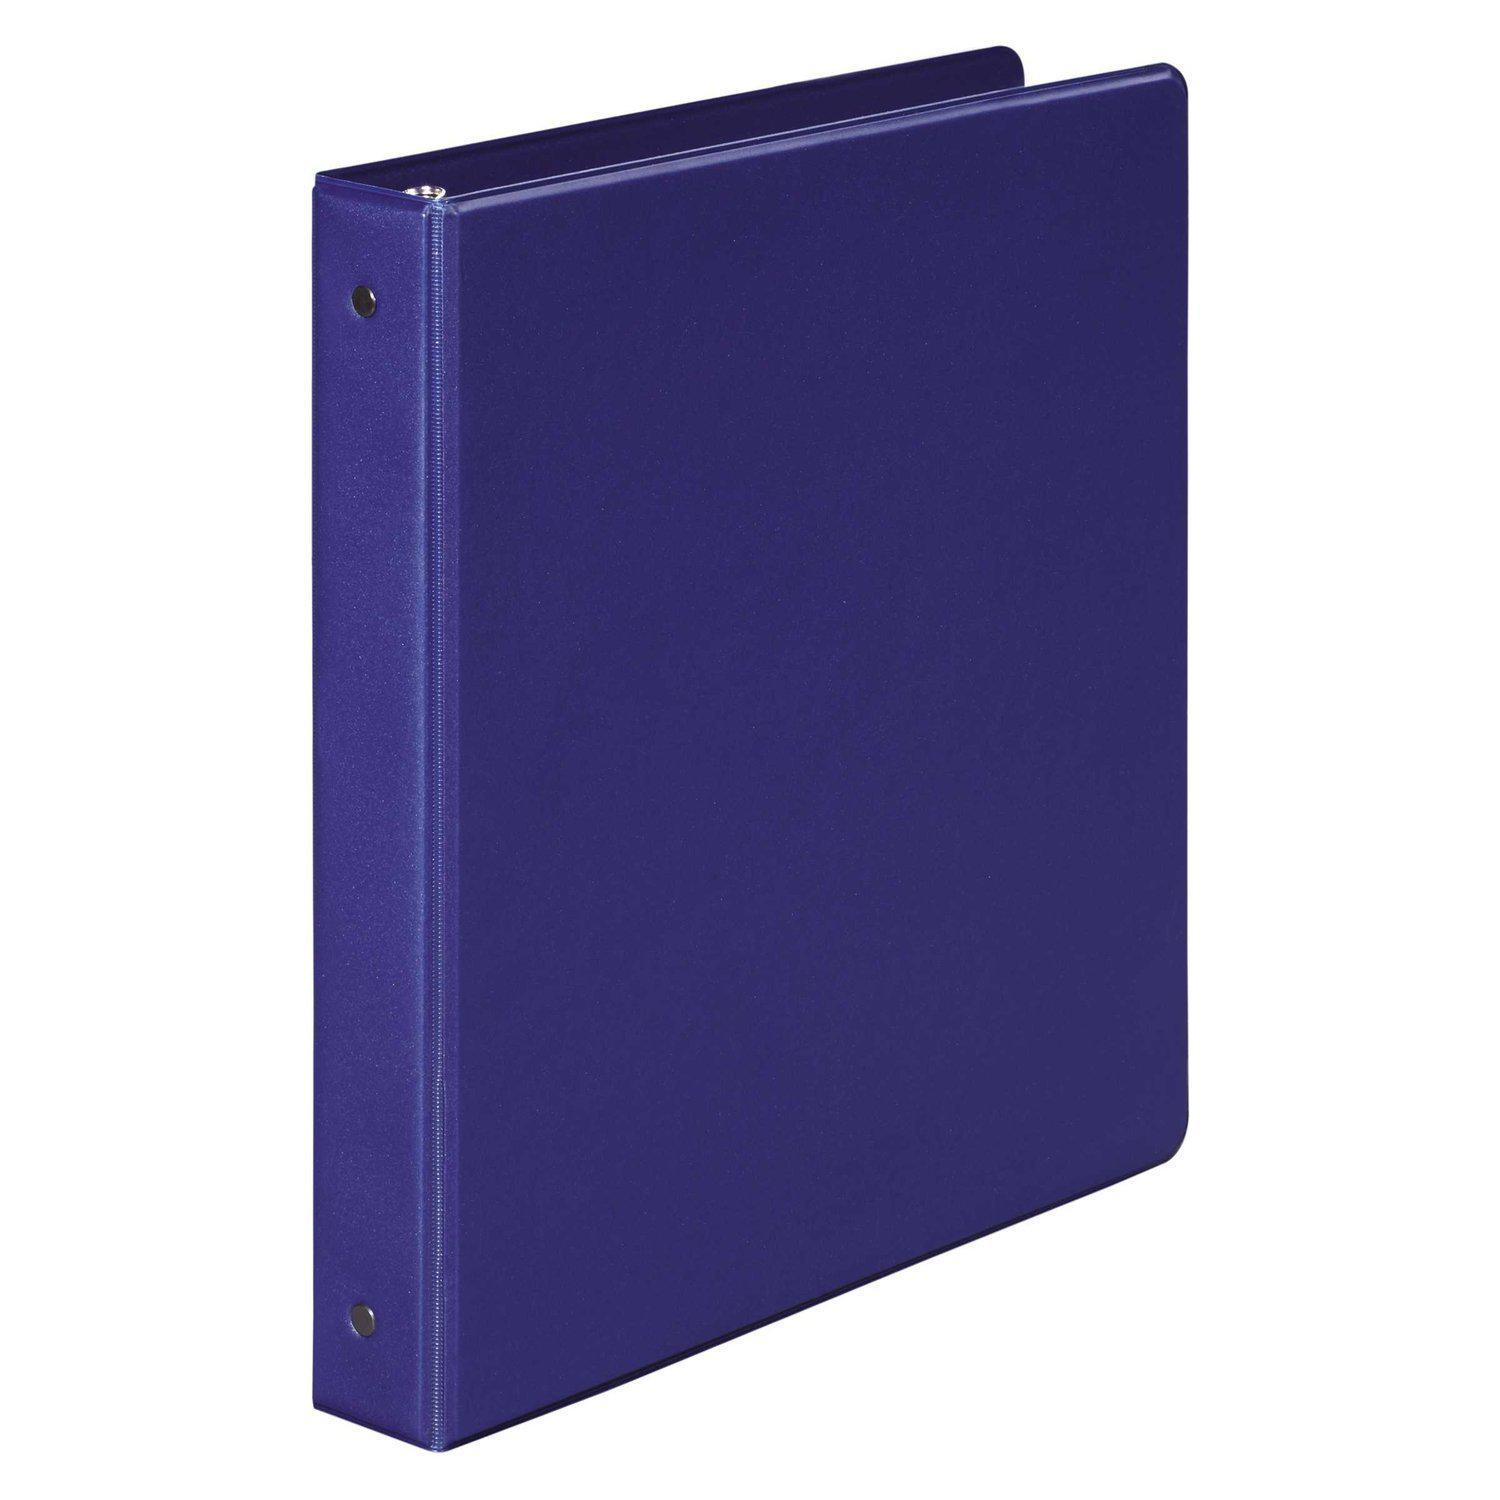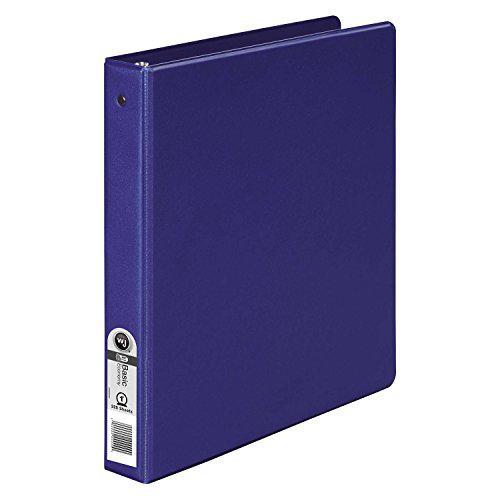The first image is the image on the left, the second image is the image on the right. Considering the images on both sides, is "The right image contains exactly one white binder standing vertically." valid? Answer yes or no. No. The first image is the image on the left, the second image is the image on the right. Evaluate the accuracy of this statement regarding the images: "There is a sticker on the spine of one of the binders.". Is it true? Answer yes or no. Yes. 